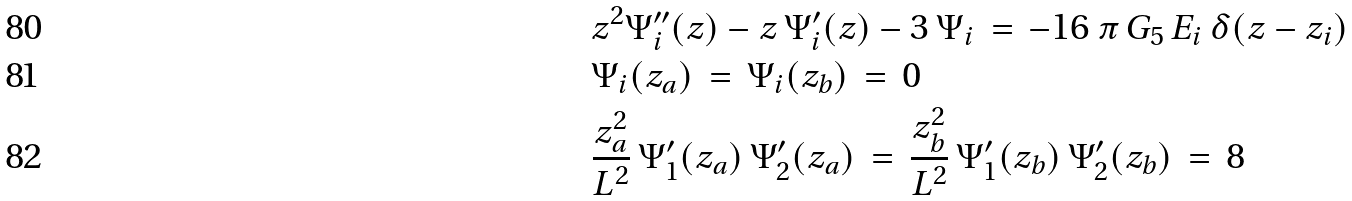Convert formula to latex. <formula><loc_0><loc_0><loc_500><loc_500>& z ^ { 2 } \Psi _ { i } ^ { \prime \prime } ( z ) - z \, \Psi _ { i } ^ { \prime } ( z ) - 3 \, \Psi _ { i } \, = \, - 1 6 \, \pi \, G _ { 5 } \, E _ { i } \, \delta ( z - z _ { i } ) \\ & \Psi _ { i } ( z _ { a } ) \, = \, \Psi _ { i } ( z _ { b } ) \, = \, 0 \\ & \frac { z _ { a } ^ { 2 } } { L ^ { 2 } } \, \Psi _ { 1 } ^ { \prime } ( z _ { a } ) \, \Psi _ { 2 } ^ { \prime } ( z _ { a } ) \, = \, \frac { z _ { b } ^ { 2 } } { L ^ { 2 } } \, \Psi _ { 1 } ^ { \prime } ( z _ { b } ) \, \Psi _ { 2 } ^ { \prime } ( z _ { b } ) \, = \, 8</formula> 